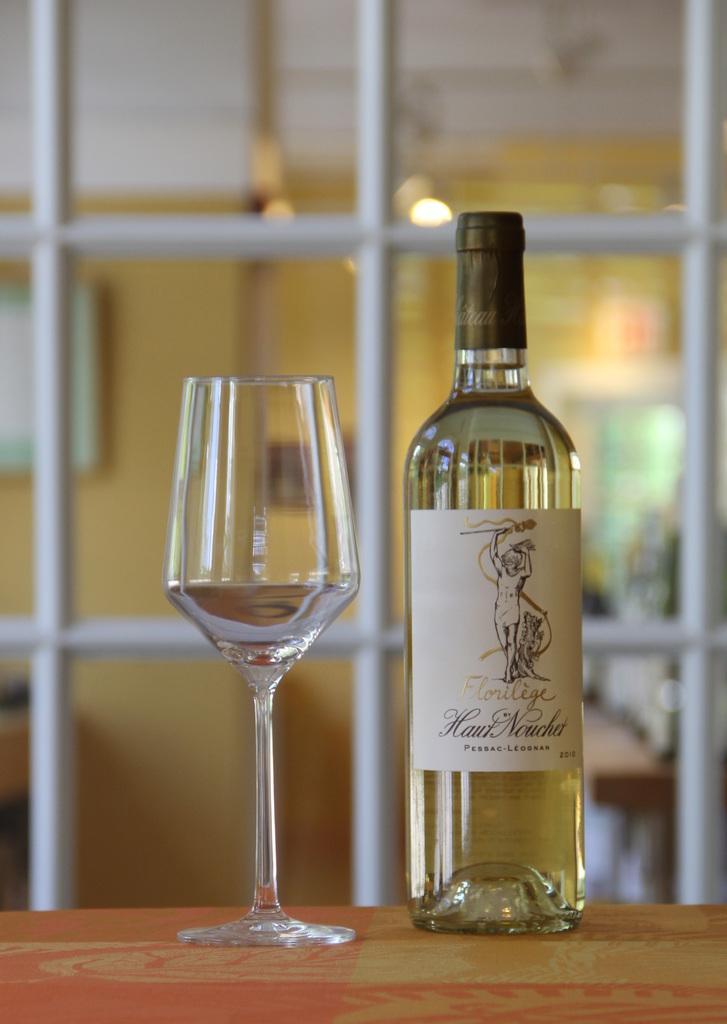Can you describe this image briefly? In this image we can see a bottle with a label on it in which there is a drink and a glass beside it placed on the top of the table. 